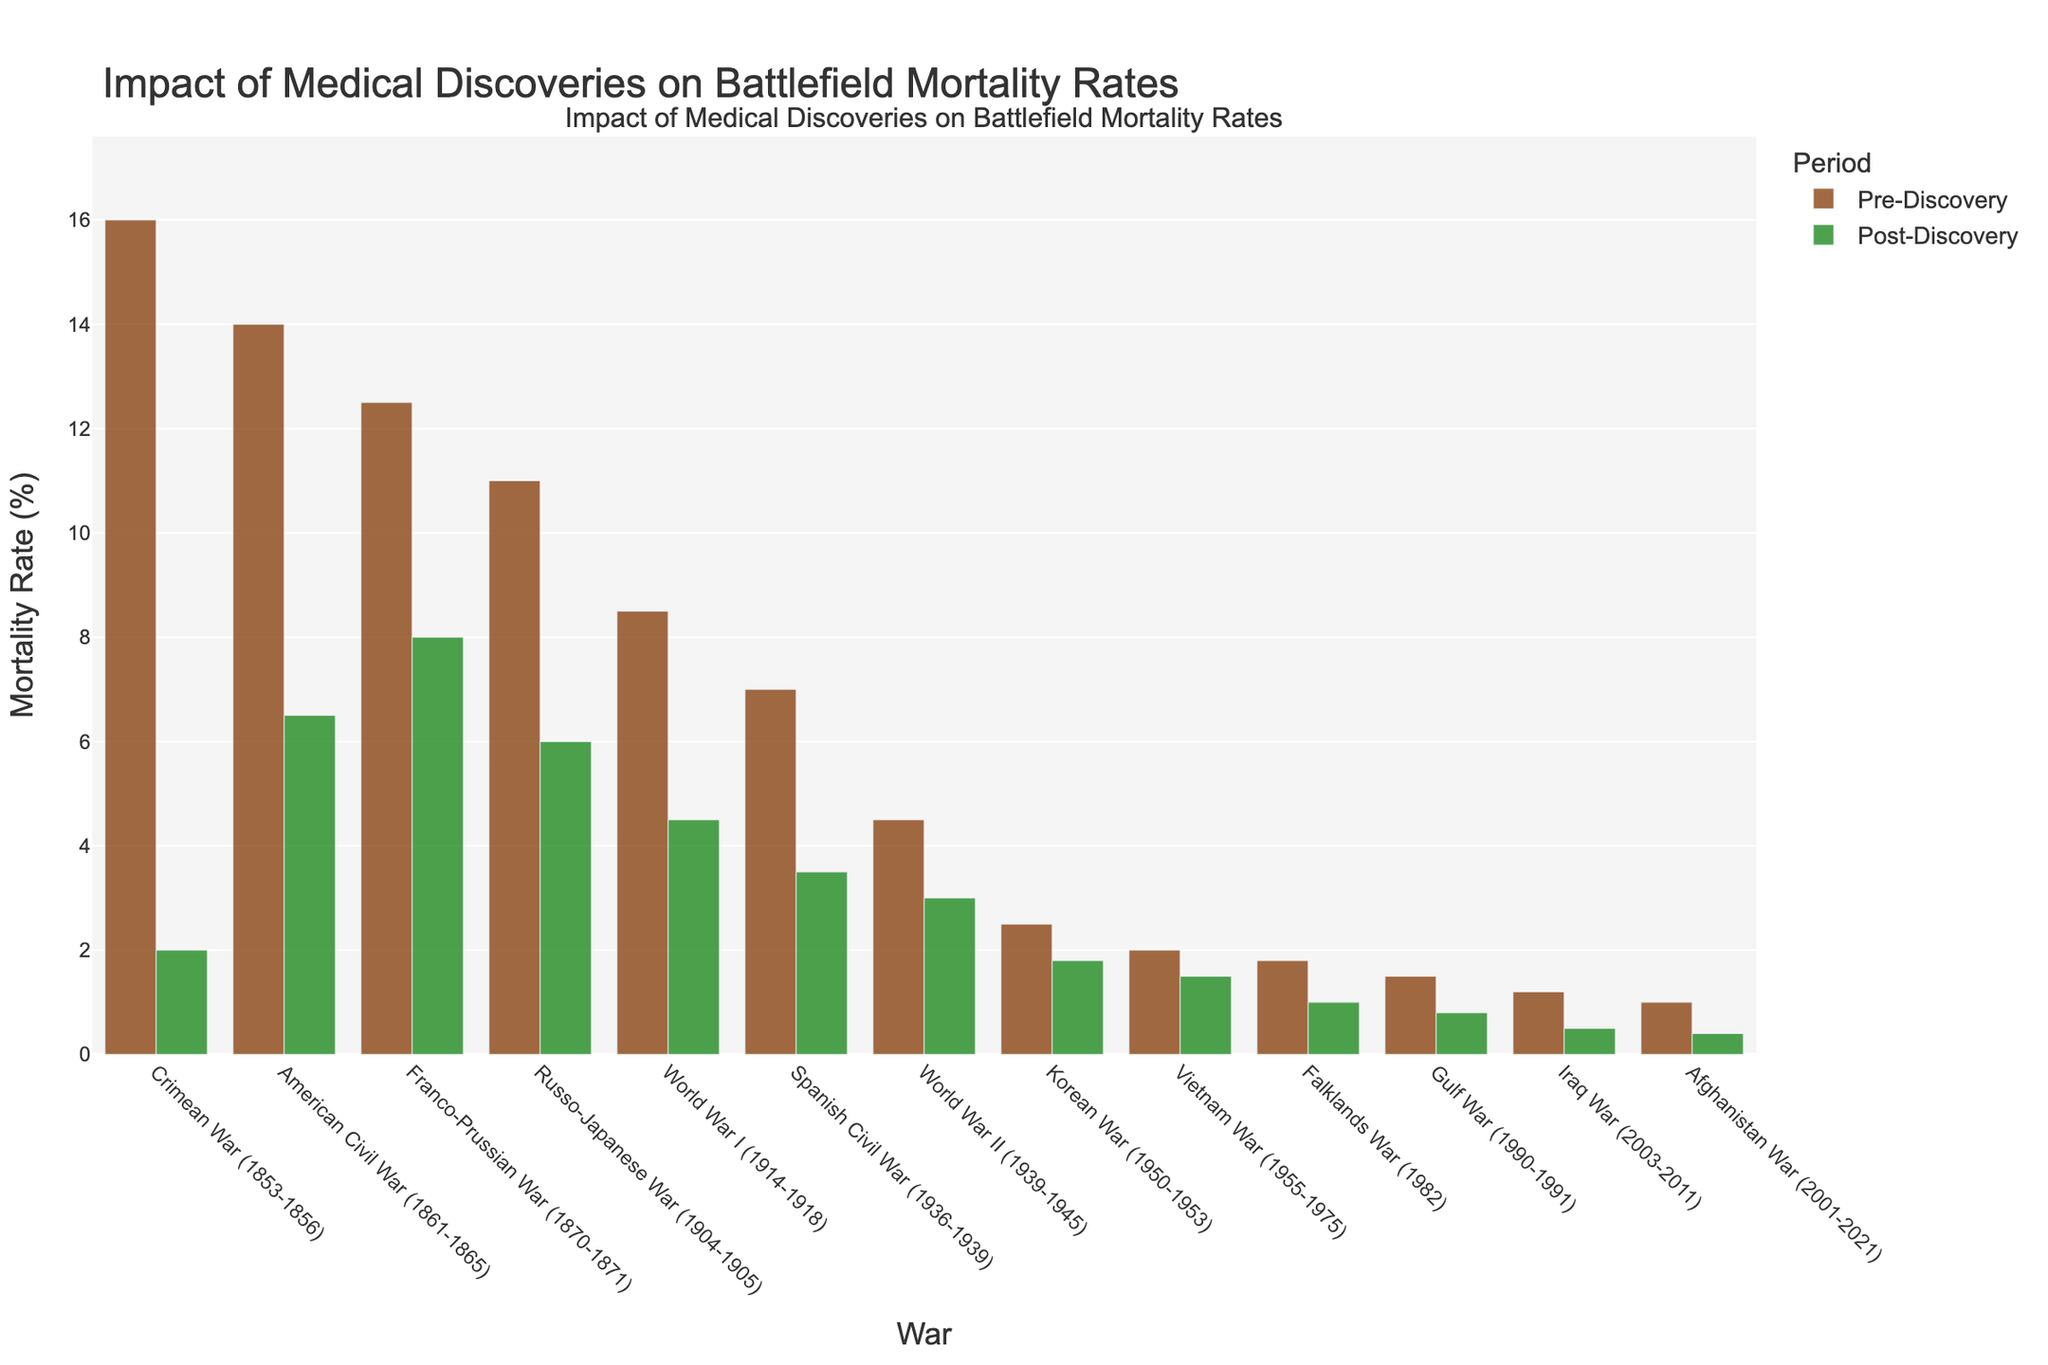Which war experienced the largest decrease in battlefield mortality rates after medical discoveries? To determine the largest decrease, we need to subtract the Post-Discovery Mortality Rate from the Pre-Discovery Mortality Rate for each war and find the maximum value. The Crimean War saw a decrease of 16.0 - 2.0 = 14.0 percentage points.
Answer: Crimean War (1853-1856) Which war had a post-discovery mortality rate of 1.5%? We need to look at the Post-Discovery Mortality Rate (%) column and match the 1.5% value to its corresponding war. The Vietnam War had a post-discovery mortality rate of 1.5%.
Answer: Vietnam War (1955-1975) What is the difference in pre-discovery mortality rates between the American Civil War and World War II? We simply subtract the pre-discovery mortality rate of World War II from that of the American Civil War. The difference is 14.0% (American Civil War) - 4.5% (World War II) = 9.5%.
Answer: 9.5% Which war had the smallest difference between pre- and post-discovery mortality rates? To find the war with the smallest difference, calculate the difference (pre-discovery minus post-discovery) for each war and identify the smallest. The Afghanistan War had a difference of 1.0% - 0.4% = 0.6%, which is the smallest.
Answer: Afghanistan War (2001-2021) What is the average pre-discovery mortality rate across all wars? To find the average, sum all pre-discovery mortality rates and divide by the number of wars. The total is 16.0 + 14.0 + 12.5 + 11.0 + 8.5 + 7.0 + 4.5 + 2.5 + 2.0 + 1.8 + 1.5 + 1.2 + 1.0 = 83.0. Divide this by 13 (number of wars), we get 83.0 / 13 ≈ 6.38%.
Answer: 6.38% Which two wars have the same post-discovery mortality rate of 6.0%? We look at the Post-Discovery Mortality Rate column to find identical values of 6.0% and identify the corresponding wars. The American Civil War and the Russo-Japanese War both have a post-discovery mortality rate of 6.0%.
Answer: American Civil War (1861-1865) and Russo-Japanese War (1904-1905) During which war did battlefield mortality rates decrease to below 2% for the first time in history? We need to find the first instance where the post-discovery mortality rate is less than 2%. The Korean War had a post-discovery mortality rate of 1.8%, and no previous wars had rates below 2%.
Answer: Korean War (1950-1953) By how much did the post-discovery mortality rate improve from World War I to World War II? Subtract the World War II post-discovery mortality rate from the World War I post-discovery mortality rate: 4.5% (World War I) - 3.0% (World War II) = 1.5%.
Answer: 1.5% Which war has a pre-discovery mortality rate close to the post-discovery rate of the Crimean War? We identify the post-discovery rate of the Crimean War, which is 2.0%, then look for a pre-discovery rate close to this value. The pre-discovery rate of the Korean War (2.5%) is the closest.
Answer: Korean War (1950-1953) What is the overall trend in battlefield mortality rates from the Crimean War to the Afghanistan War? Examine the bars in chronological order to see how both pre-discovery and post-discovery rates change. Both rates generally decrease over time, indicating improved medical practices and reduced mortality throughout history.
Answer: Decreasing trend 